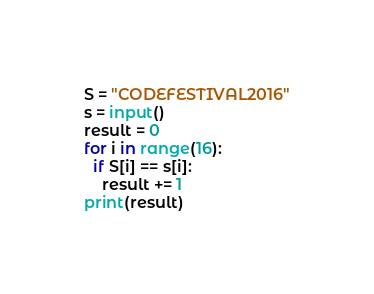<code> <loc_0><loc_0><loc_500><loc_500><_Python_>S = "CODEFESTIVAL2016"
s = input()
result = 0
for i in range(16):
  if S[i] == s[i]:
    result += 1
print(result)</code> 